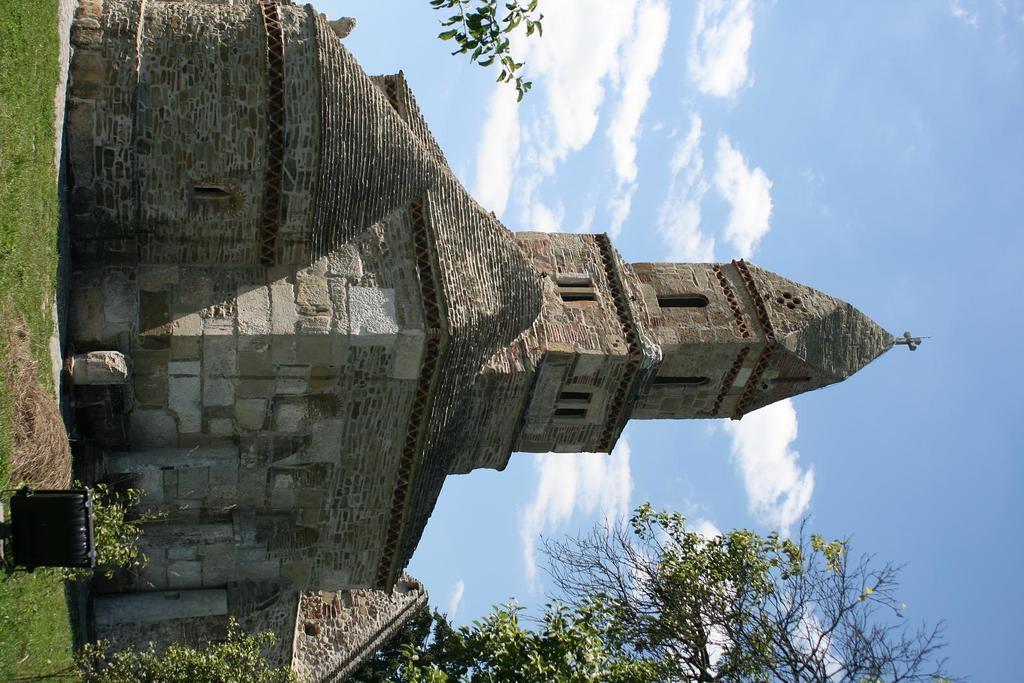Could you give a brief overview of what you see in this image? In this image we can see a building with windows and brick walls. On the ground there is grass. Also we can see branches of trees. In the background there is sky with clouds. 